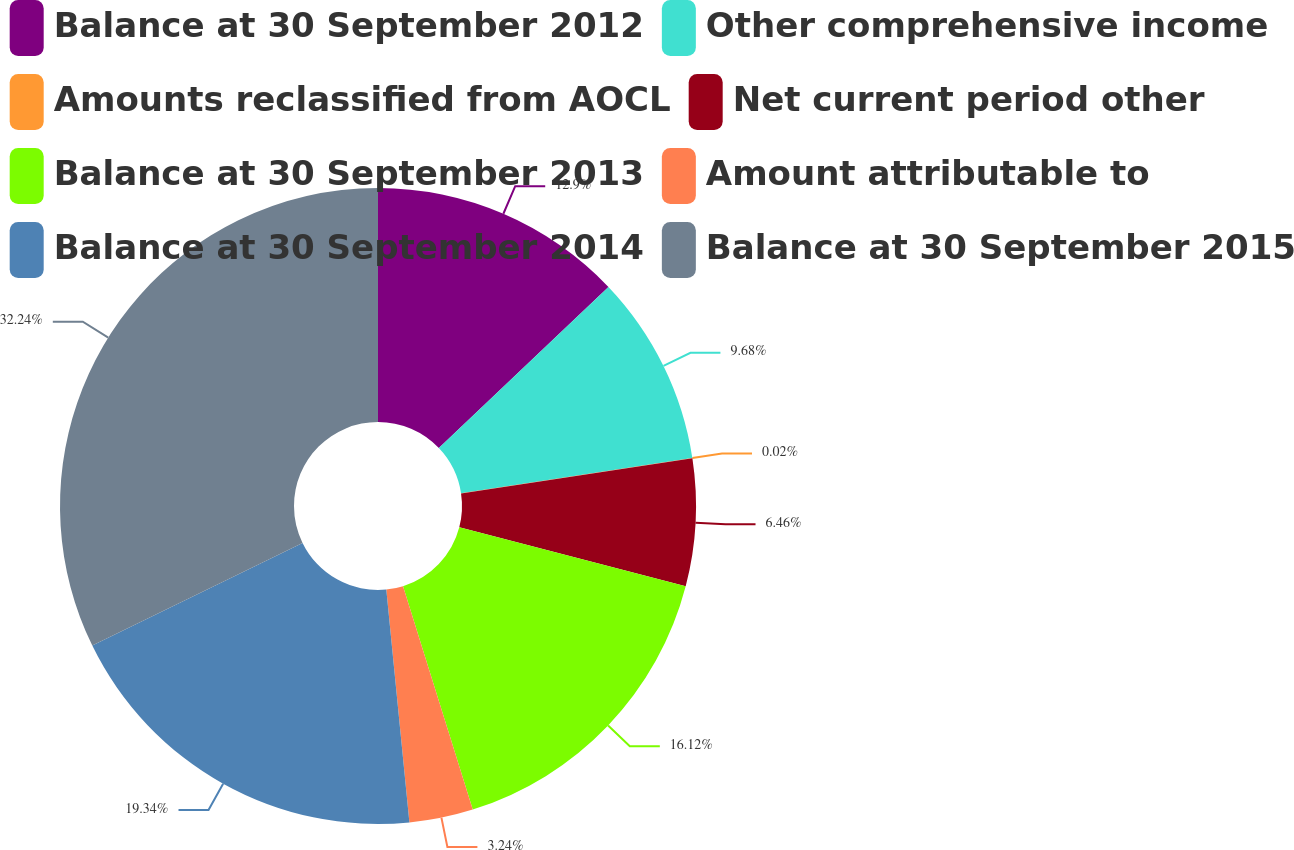Convert chart. <chart><loc_0><loc_0><loc_500><loc_500><pie_chart><fcel>Balance at 30 September 2012<fcel>Other comprehensive income<fcel>Amounts reclassified from AOCL<fcel>Net current period other<fcel>Balance at 30 September 2013<fcel>Amount attributable to<fcel>Balance at 30 September 2014<fcel>Balance at 30 September 2015<nl><fcel>12.9%<fcel>9.68%<fcel>0.02%<fcel>6.46%<fcel>16.12%<fcel>3.24%<fcel>19.34%<fcel>32.23%<nl></chart> 